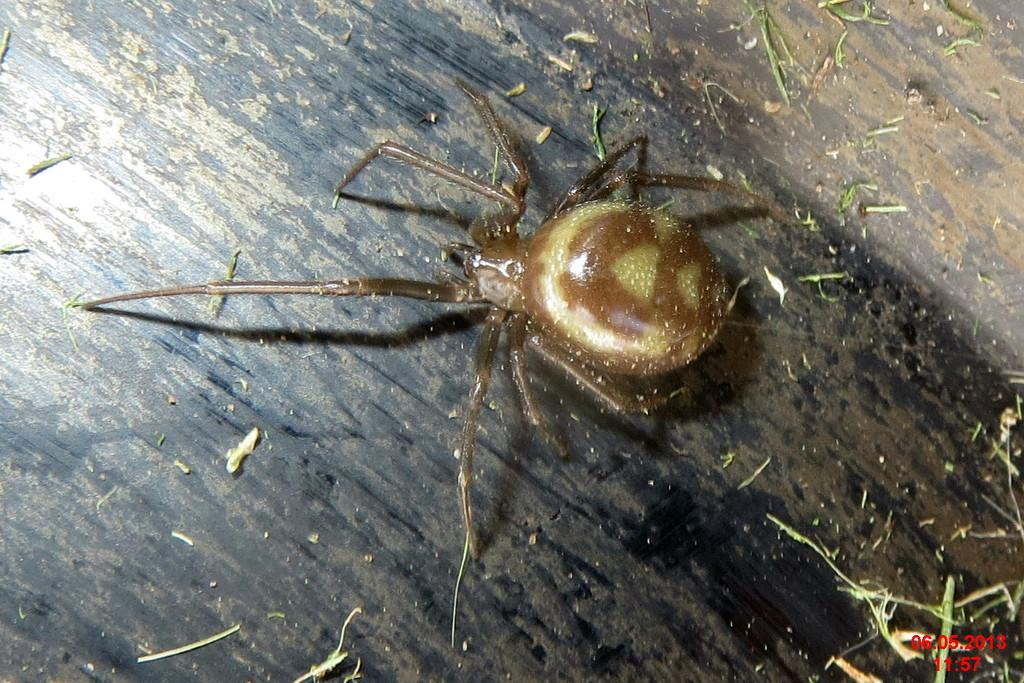What type of creature is present in the image? There is an insect in the image. What color is the insect? The insect is dark brown in color. What is the background or surface the insect is on? The insect is on a black surface. How many dolls are sitting on the cherries in the image? There are no dolls or cherries present in the image; it features an insect on a black surface. 